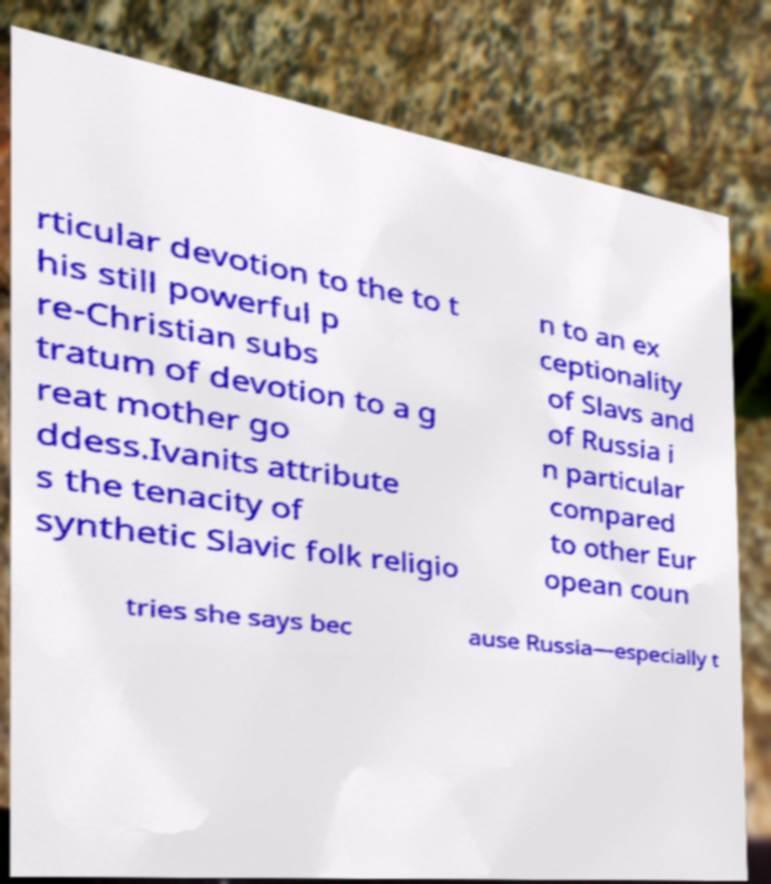Can you read and provide the text displayed in the image?This photo seems to have some interesting text. Can you extract and type it out for me? rticular devotion to the to t his still powerful p re-Christian subs tratum of devotion to a g reat mother go ddess.Ivanits attribute s the tenacity of synthetic Slavic folk religio n to an ex ceptionality of Slavs and of Russia i n particular compared to other Eur opean coun tries she says bec ause Russia—especially t 